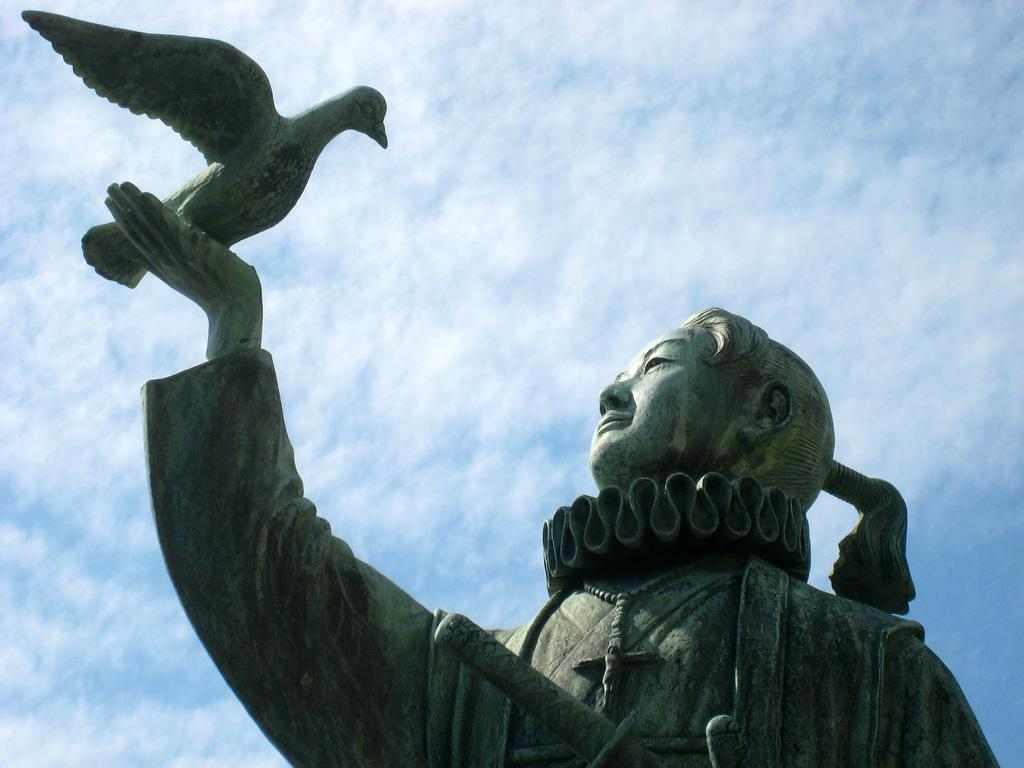What is the main subject of the image? The main subject of the image is a sculpture of a person. What is the person in the sculpture doing? The person in the sculpture is holding a bird. What can be seen in the background of the image? Sky is visible at the top of the image. How many flocks of wool are being used to create the sculpture in the image? There is no mention of flocks of wool or any material used to create the sculpture in the image. 